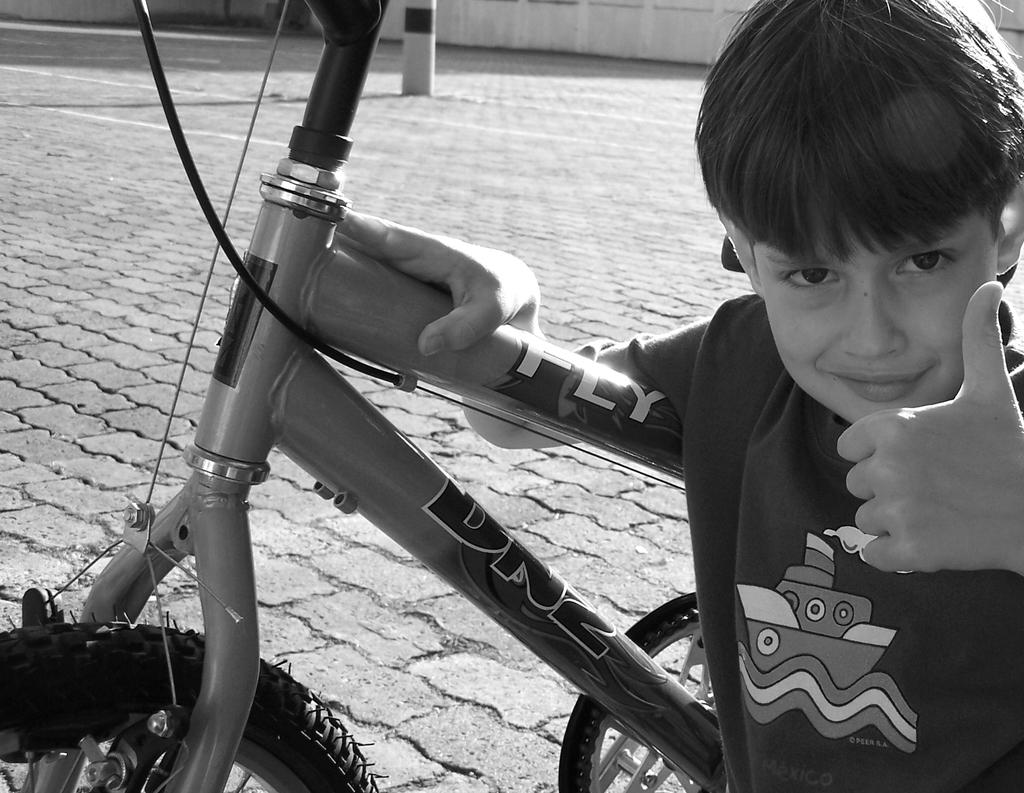Who is present in the image? There is a boy in the image. What is on the ground near the boy? There is a bicycle on the ground in the image. What can be seen in the background of the image? There is a pole and other objects in the background of the image. What is the color scheme of the image? The image is black and white in color. Can you see any boats in the harbor in the image? There is no harbor or boats present in the image; it features a boy, a bicycle, and a background with a pole and other objects. Is the boy holding a rifle in the image? There is no rifle present in the image; the boy is not holding any weapon. 